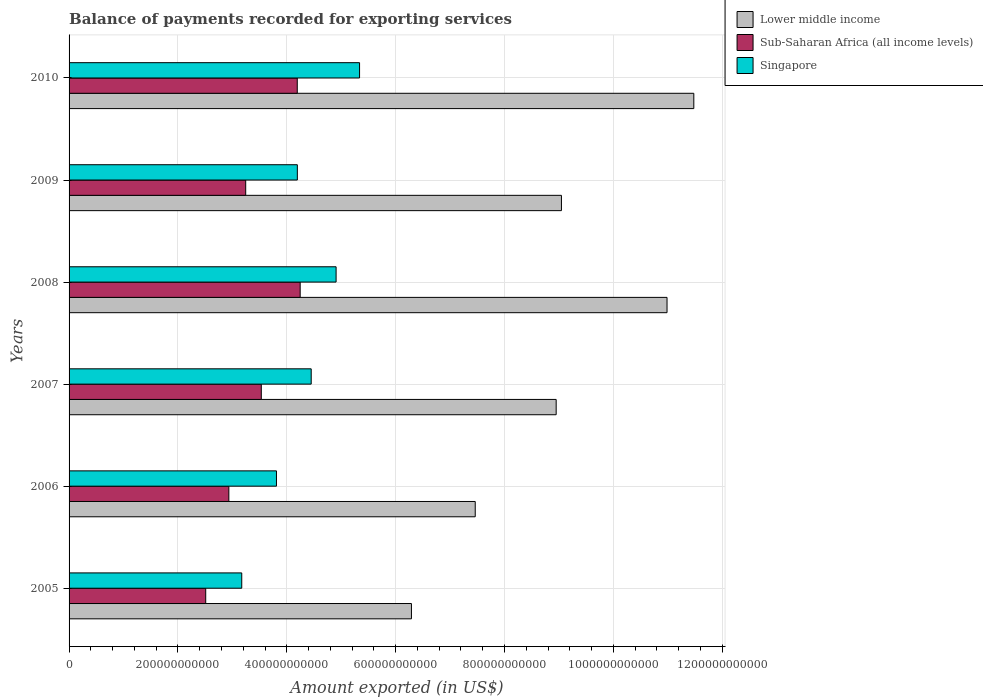Are the number of bars per tick equal to the number of legend labels?
Give a very brief answer. Yes. Are the number of bars on each tick of the Y-axis equal?
Offer a terse response. Yes. How many bars are there on the 5th tick from the bottom?
Your answer should be compact. 3. What is the label of the 2nd group of bars from the top?
Offer a terse response. 2009. In how many cases, is the number of bars for a given year not equal to the number of legend labels?
Provide a succinct answer. 0. What is the amount exported in Sub-Saharan Africa (all income levels) in 2009?
Your response must be concise. 3.25e+11. Across all years, what is the maximum amount exported in Lower middle income?
Your answer should be compact. 1.15e+12. Across all years, what is the minimum amount exported in Sub-Saharan Africa (all income levels)?
Make the answer very short. 2.51e+11. In which year was the amount exported in Lower middle income minimum?
Keep it short and to the point. 2005. What is the total amount exported in Lower middle income in the graph?
Provide a short and direct response. 5.42e+12. What is the difference between the amount exported in Lower middle income in 2007 and that in 2009?
Your answer should be compact. -9.69e+09. What is the difference between the amount exported in Sub-Saharan Africa (all income levels) in 2010 and the amount exported in Singapore in 2005?
Your answer should be very brief. 1.02e+11. What is the average amount exported in Sub-Saharan Africa (all income levels) per year?
Your answer should be very brief. 3.44e+11. In the year 2006, what is the difference between the amount exported in Sub-Saharan Africa (all income levels) and amount exported in Lower middle income?
Your answer should be compact. -4.53e+11. In how many years, is the amount exported in Lower middle income greater than 200000000000 US$?
Offer a very short reply. 6. What is the ratio of the amount exported in Lower middle income in 2005 to that in 2009?
Your answer should be compact. 0.7. Is the amount exported in Singapore in 2005 less than that in 2006?
Make the answer very short. Yes. What is the difference between the highest and the second highest amount exported in Lower middle income?
Ensure brevity in your answer.  4.92e+1. What is the difference between the highest and the lowest amount exported in Singapore?
Offer a very short reply. 2.16e+11. In how many years, is the amount exported in Singapore greater than the average amount exported in Singapore taken over all years?
Keep it short and to the point. 3. Is the sum of the amount exported in Sub-Saharan Africa (all income levels) in 2005 and 2007 greater than the maximum amount exported in Lower middle income across all years?
Make the answer very short. No. What does the 2nd bar from the top in 2007 represents?
Offer a very short reply. Sub-Saharan Africa (all income levels). What does the 3rd bar from the bottom in 2009 represents?
Keep it short and to the point. Singapore. Are all the bars in the graph horizontal?
Your response must be concise. Yes. What is the difference between two consecutive major ticks on the X-axis?
Your answer should be compact. 2.00e+11. Are the values on the major ticks of X-axis written in scientific E-notation?
Offer a very short reply. No. Where does the legend appear in the graph?
Your answer should be very brief. Top right. How many legend labels are there?
Make the answer very short. 3. What is the title of the graph?
Provide a short and direct response. Balance of payments recorded for exporting services. What is the label or title of the X-axis?
Offer a very short reply. Amount exported (in US$). What is the label or title of the Y-axis?
Offer a very short reply. Years. What is the Amount exported (in US$) in Lower middle income in 2005?
Provide a succinct answer. 6.29e+11. What is the Amount exported (in US$) in Sub-Saharan Africa (all income levels) in 2005?
Keep it short and to the point. 2.51e+11. What is the Amount exported (in US$) of Singapore in 2005?
Provide a succinct answer. 3.17e+11. What is the Amount exported (in US$) of Lower middle income in 2006?
Your answer should be very brief. 7.46e+11. What is the Amount exported (in US$) in Sub-Saharan Africa (all income levels) in 2006?
Your response must be concise. 2.94e+11. What is the Amount exported (in US$) in Singapore in 2006?
Provide a succinct answer. 3.81e+11. What is the Amount exported (in US$) of Lower middle income in 2007?
Ensure brevity in your answer.  8.95e+11. What is the Amount exported (in US$) in Sub-Saharan Africa (all income levels) in 2007?
Offer a terse response. 3.53e+11. What is the Amount exported (in US$) in Singapore in 2007?
Provide a short and direct response. 4.45e+11. What is the Amount exported (in US$) of Lower middle income in 2008?
Ensure brevity in your answer.  1.10e+12. What is the Amount exported (in US$) of Sub-Saharan Africa (all income levels) in 2008?
Your response must be concise. 4.25e+11. What is the Amount exported (in US$) in Singapore in 2008?
Offer a very short reply. 4.91e+11. What is the Amount exported (in US$) of Lower middle income in 2009?
Provide a short and direct response. 9.05e+11. What is the Amount exported (in US$) of Sub-Saharan Africa (all income levels) in 2009?
Make the answer very short. 3.25e+11. What is the Amount exported (in US$) in Singapore in 2009?
Offer a very short reply. 4.19e+11. What is the Amount exported (in US$) in Lower middle income in 2010?
Provide a short and direct response. 1.15e+12. What is the Amount exported (in US$) of Sub-Saharan Africa (all income levels) in 2010?
Provide a succinct answer. 4.19e+11. What is the Amount exported (in US$) in Singapore in 2010?
Offer a very short reply. 5.34e+11. Across all years, what is the maximum Amount exported (in US$) in Lower middle income?
Your response must be concise. 1.15e+12. Across all years, what is the maximum Amount exported (in US$) of Sub-Saharan Africa (all income levels)?
Your response must be concise. 4.25e+11. Across all years, what is the maximum Amount exported (in US$) of Singapore?
Offer a terse response. 5.34e+11. Across all years, what is the minimum Amount exported (in US$) of Lower middle income?
Provide a short and direct response. 6.29e+11. Across all years, what is the minimum Amount exported (in US$) in Sub-Saharan Africa (all income levels)?
Give a very brief answer. 2.51e+11. Across all years, what is the minimum Amount exported (in US$) in Singapore?
Keep it short and to the point. 3.17e+11. What is the total Amount exported (in US$) of Lower middle income in the graph?
Make the answer very short. 5.42e+12. What is the total Amount exported (in US$) in Sub-Saharan Africa (all income levels) in the graph?
Ensure brevity in your answer.  2.07e+12. What is the total Amount exported (in US$) in Singapore in the graph?
Provide a short and direct response. 2.59e+12. What is the difference between the Amount exported (in US$) of Lower middle income in 2005 and that in 2006?
Your response must be concise. -1.17e+11. What is the difference between the Amount exported (in US$) of Sub-Saharan Africa (all income levels) in 2005 and that in 2006?
Provide a short and direct response. -4.25e+1. What is the difference between the Amount exported (in US$) in Singapore in 2005 and that in 2006?
Offer a terse response. -6.38e+1. What is the difference between the Amount exported (in US$) of Lower middle income in 2005 and that in 2007?
Offer a very short reply. -2.66e+11. What is the difference between the Amount exported (in US$) of Sub-Saharan Africa (all income levels) in 2005 and that in 2007?
Offer a terse response. -1.02e+11. What is the difference between the Amount exported (in US$) in Singapore in 2005 and that in 2007?
Your answer should be compact. -1.28e+11. What is the difference between the Amount exported (in US$) of Lower middle income in 2005 and that in 2008?
Offer a very short reply. -4.70e+11. What is the difference between the Amount exported (in US$) in Sub-Saharan Africa (all income levels) in 2005 and that in 2008?
Offer a very short reply. -1.74e+11. What is the difference between the Amount exported (in US$) of Singapore in 2005 and that in 2008?
Your answer should be very brief. -1.73e+11. What is the difference between the Amount exported (in US$) in Lower middle income in 2005 and that in 2009?
Make the answer very short. -2.76e+11. What is the difference between the Amount exported (in US$) in Sub-Saharan Africa (all income levels) in 2005 and that in 2009?
Give a very brief answer. -7.35e+1. What is the difference between the Amount exported (in US$) in Singapore in 2005 and that in 2009?
Your response must be concise. -1.02e+11. What is the difference between the Amount exported (in US$) in Lower middle income in 2005 and that in 2010?
Your response must be concise. -5.19e+11. What is the difference between the Amount exported (in US$) in Sub-Saharan Africa (all income levels) in 2005 and that in 2010?
Provide a succinct answer. -1.68e+11. What is the difference between the Amount exported (in US$) in Singapore in 2005 and that in 2010?
Give a very brief answer. -2.16e+11. What is the difference between the Amount exported (in US$) of Lower middle income in 2006 and that in 2007?
Your answer should be compact. -1.49e+11. What is the difference between the Amount exported (in US$) of Sub-Saharan Africa (all income levels) in 2006 and that in 2007?
Make the answer very short. -5.96e+1. What is the difference between the Amount exported (in US$) in Singapore in 2006 and that in 2007?
Keep it short and to the point. -6.38e+1. What is the difference between the Amount exported (in US$) of Lower middle income in 2006 and that in 2008?
Ensure brevity in your answer.  -3.52e+11. What is the difference between the Amount exported (in US$) of Sub-Saharan Africa (all income levels) in 2006 and that in 2008?
Your answer should be very brief. -1.31e+11. What is the difference between the Amount exported (in US$) in Singapore in 2006 and that in 2008?
Your response must be concise. -1.10e+11. What is the difference between the Amount exported (in US$) of Lower middle income in 2006 and that in 2009?
Your answer should be compact. -1.58e+11. What is the difference between the Amount exported (in US$) in Sub-Saharan Africa (all income levels) in 2006 and that in 2009?
Provide a short and direct response. -3.10e+1. What is the difference between the Amount exported (in US$) of Singapore in 2006 and that in 2009?
Offer a terse response. -3.83e+1. What is the difference between the Amount exported (in US$) in Lower middle income in 2006 and that in 2010?
Provide a succinct answer. -4.02e+11. What is the difference between the Amount exported (in US$) of Sub-Saharan Africa (all income levels) in 2006 and that in 2010?
Your answer should be very brief. -1.26e+11. What is the difference between the Amount exported (in US$) in Singapore in 2006 and that in 2010?
Your answer should be very brief. -1.53e+11. What is the difference between the Amount exported (in US$) in Lower middle income in 2007 and that in 2008?
Offer a very short reply. -2.04e+11. What is the difference between the Amount exported (in US$) in Sub-Saharan Africa (all income levels) in 2007 and that in 2008?
Your response must be concise. -7.14e+1. What is the difference between the Amount exported (in US$) in Singapore in 2007 and that in 2008?
Provide a succinct answer. -4.57e+1. What is the difference between the Amount exported (in US$) in Lower middle income in 2007 and that in 2009?
Keep it short and to the point. -9.69e+09. What is the difference between the Amount exported (in US$) in Sub-Saharan Africa (all income levels) in 2007 and that in 2009?
Provide a succinct answer. 2.87e+1. What is the difference between the Amount exported (in US$) in Singapore in 2007 and that in 2009?
Provide a short and direct response. 2.55e+1. What is the difference between the Amount exported (in US$) of Lower middle income in 2007 and that in 2010?
Keep it short and to the point. -2.53e+11. What is the difference between the Amount exported (in US$) of Sub-Saharan Africa (all income levels) in 2007 and that in 2010?
Provide a short and direct response. -6.61e+1. What is the difference between the Amount exported (in US$) of Singapore in 2007 and that in 2010?
Offer a very short reply. -8.88e+1. What is the difference between the Amount exported (in US$) of Lower middle income in 2008 and that in 2009?
Ensure brevity in your answer.  1.94e+11. What is the difference between the Amount exported (in US$) of Sub-Saharan Africa (all income levels) in 2008 and that in 2009?
Give a very brief answer. 1.00e+11. What is the difference between the Amount exported (in US$) in Singapore in 2008 and that in 2009?
Offer a terse response. 7.12e+1. What is the difference between the Amount exported (in US$) in Lower middle income in 2008 and that in 2010?
Give a very brief answer. -4.92e+1. What is the difference between the Amount exported (in US$) in Sub-Saharan Africa (all income levels) in 2008 and that in 2010?
Keep it short and to the point. 5.35e+09. What is the difference between the Amount exported (in US$) in Singapore in 2008 and that in 2010?
Offer a terse response. -4.31e+1. What is the difference between the Amount exported (in US$) in Lower middle income in 2009 and that in 2010?
Your response must be concise. -2.43e+11. What is the difference between the Amount exported (in US$) of Sub-Saharan Africa (all income levels) in 2009 and that in 2010?
Offer a very short reply. -9.47e+1. What is the difference between the Amount exported (in US$) of Singapore in 2009 and that in 2010?
Ensure brevity in your answer.  -1.14e+11. What is the difference between the Amount exported (in US$) of Lower middle income in 2005 and the Amount exported (in US$) of Sub-Saharan Africa (all income levels) in 2006?
Your answer should be compact. 3.35e+11. What is the difference between the Amount exported (in US$) in Lower middle income in 2005 and the Amount exported (in US$) in Singapore in 2006?
Provide a short and direct response. 2.48e+11. What is the difference between the Amount exported (in US$) in Sub-Saharan Africa (all income levels) in 2005 and the Amount exported (in US$) in Singapore in 2006?
Keep it short and to the point. -1.30e+11. What is the difference between the Amount exported (in US$) in Lower middle income in 2005 and the Amount exported (in US$) in Sub-Saharan Africa (all income levels) in 2007?
Provide a short and direct response. 2.76e+11. What is the difference between the Amount exported (in US$) of Lower middle income in 2005 and the Amount exported (in US$) of Singapore in 2007?
Give a very brief answer. 1.84e+11. What is the difference between the Amount exported (in US$) in Sub-Saharan Africa (all income levels) in 2005 and the Amount exported (in US$) in Singapore in 2007?
Your answer should be compact. -1.94e+11. What is the difference between the Amount exported (in US$) of Lower middle income in 2005 and the Amount exported (in US$) of Sub-Saharan Africa (all income levels) in 2008?
Offer a very short reply. 2.04e+11. What is the difference between the Amount exported (in US$) in Lower middle income in 2005 and the Amount exported (in US$) in Singapore in 2008?
Your answer should be very brief. 1.38e+11. What is the difference between the Amount exported (in US$) in Sub-Saharan Africa (all income levels) in 2005 and the Amount exported (in US$) in Singapore in 2008?
Give a very brief answer. -2.40e+11. What is the difference between the Amount exported (in US$) in Lower middle income in 2005 and the Amount exported (in US$) in Sub-Saharan Africa (all income levels) in 2009?
Give a very brief answer. 3.05e+11. What is the difference between the Amount exported (in US$) in Lower middle income in 2005 and the Amount exported (in US$) in Singapore in 2009?
Your response must be concise. 2.10e+11. What is the difference between the Amount exported (in US$) in Sub-Saharan Africa (all income levels) in 2005 and the Amount exported (in US$) in Singapore in 2009?
Your answer should be compact. -1.68e+11. What is the difference between the Amount exported (in US$) in Lower middle income in 2005 and the Amount exported (in US$) in Sub-Saharan Africa (all income levels) in 2010?
Offer a terse response. 2.10e+11. What is the difference between the Amount exported (in US$) in Lower middle income in 2005 and the Amount exported (in US$) in Singapore in 2010?
Give a very brief answer. 9.53e+1. What is the difference between the Amount exported (in US$) of Sub-Saharan Africa (all income levels) in 2005 and the Amount exported (in US$) of Singapore in 2010?
Offer a very short reply. -2.83e+11. What is the difference between the Amount exported (in US$) of Lower middle income in 2006 and the Amount exported (in US$) of Sub-Saharan Africa (all income levels) in 2007?
Provide a short and direct response. 3.93e+11. What is the difference between the Amount exported (in US$) of Lower middle income in 2006 and the Amount exported (in US$) of Singapore in 2007?
Make the answer very short. 3.01e+11. What is the difference between the Amount exported (in US$) of Sub-Saharan Africa (all income levels) in 2006 and the Amount exported (in US$) of Singapore in 2007?
Offer a terse response. -1.51e+11. What is the difference between the Amount exported (in US$) of Lower middle income in 2006 and the Amount exported (in US$) of Sub-Saharan Africa (all income levels) in 2008?
Your answer should be very brief. 3.22e+11. What is the difference between the Amount exported (in US$) of Lower middle income in 2006 and the Amount exported (in US$) of Singapore in 2008?
Make the answer very short. 2.56e+11. What is the difference between the Amount exported (in US$) in Sub-Saharan Africa (all income levels) in 2006 and the Amount exported (in US$) in Singapore in 2008?
Your answer should be very brief. -1.97e+11. What is the difference between the Amount exported (in US$) in Lower middle income in 2006 and the Amount exported (in US$) in Sub-Saharan Africa (all income levels) in 2009?
Provide a short and direct response. 4.22e+11. What is the difference between the Amount exported (in US$) in Lower middle income in 2006 and the Amount exported (in US$) in Singapore in 2009?
Your answer should be compact. 3.27e+11. What is the difference between the Amount exported (in US$) of Sub-Saharan Africa (all income levels) in 2006 and the Amount exported (in US$) of Singapore in 2009?
Your answer should be very brief. -1.26e+11. What is the difference between the Amount exported (in US$) in Lower middle income in 2006 and the Amount exported (in US$) in Sub-Saharan Africa (all income levels) in 2010?
Make the answer very short. 3.27e+11. What is the difference between the Amount exported (in US$) in Lower middle income in 2006 and the Amount exported (in US$) in Singapore in 2010?
Provide a succinct answer. 2.13e+11. What is the difference between the Amount exported (in US$) in Sub-Saharan Africa (all income levels) in 2006 and the Amount exported (in US$) in Singapore in 2010?
Ensure brevity in your answer.  -2.40e+11. What is the difference between the Amount exported (in US$) in Lower middle income in 2007 and the Amount exported (in US$) in Sub-Saharan Africa (all income levels) in 2008?
Provide a succinct answer. 4.70e+11. What is the difference between the Amount exported (in US$) in Lower middle income in 2007 and the Amount exported (in US$) in Singapore in 2008?
Your answer should be compact. 4.04e+11. What is the difference between the Amount exported (in US$) of Sub-Saharan Africa (all income levels) in 2007 and the Amount exported (in US$) of Singapore in 2008?
Offer a very short reply. -1.37e+11. What is the difference between the Amount exported (in US$) in Lower middle income in 2007 and the Amount exported (in US$) in Sub-Saharan Africa (all income levels) in 2009?
Provide a short and direct response. 5.70e+11. What is the difference between the Amount exported (in US$) of Lower middle income in 2007 and the Amount exported (in US$) of Singapore in 2009?
Your answer should be compact. 4.76e+11. What is the difference between the Amount exported (in US$) of Sub-Saharan Africa (all income levels) in 2007 and the Amount exported (in US$) of Singapore in 2009?
Your response must be concise. -6.62e+1. What is the difference between the Amount exported (in US$) in Lower middle income in 2007 and the Amount exported (in US$) in Sub-Saharan Africa (all income levels) in 2010?
Your answer should be very brief. 4.76e+11. What is the difference between the Amount exported (in US$) of Lower middle income in 2007 and the Amount exported (in US$) of Singapore in 2010?
Your response must be concise. 3.61e+11. What is the difference between the Amount exported (in US$) in Sub-Saharan Africa (all income levels) in 2007 and the Amount exported (in US$) in Singapore in 2010?
Provide a short and direct response. -1.81e+11. What is the difference between the Amount exported (in US$) of Lower middle income in 2008 and the Amount exported (in US$) of Sub-Saharan Africa (all income levels) in 2009?
Your response must be concise. 7.74e+11. What is the difference between the Amount exported (in US$) in Lower middle income in 2008 and the Amount exported (in US$) in Singapore in 2009?
Your response must be concise. 6.79e+11. What is the difference between the Amount exported (in US$) of Sub-Saharan Africa (all income levels) in 2008 and the Amount exported (in US$) of Singapore in 2009?
Keep it short and to the point. 5.20e+09. What is the difference between the Amount exported (in US$) of Lower middle income in 2008 and the Amount exported (in US$) of Sub-Saharan Africa (all income levels) in 2010?
Offer a terse response. 6.79e+11. What is the difference between the Amount exported (in US$) in Lower middle income in 2008 and the Amount exported (in US$) in Singapore in 2010?
Keep it short and to the point. 5.65e+11. What is the difference between the Amount exported (in US$) in Sub-Saharan Africa (all income levels) in 2008 and the Amount exported (in US$) in Singapore in 2010?
Ensure brevity in your answer.  -1.09e+11. What is the difference between the Amount exported (in US$) in Lower middle income in 2009 and the Amount exported (in US$) in Sub-Saharan Africa (all income levels) in 2010?
Your answer should be compact. 4.85e+11. What is the difference between the Amount exported (in US$) of Lower middle income in 2009 and the Amount exported (in US$) of Singapore in 2010?
Your response must be concise. 3.71e+11. What is the difference between the Amount exported (in US$) in Sub-Saharan Africa (all income levels) in 2009 and the Amount exported (in US$) in Singapore in 2010?
Provide a succinct answer. -2.09e+11. What is the average Amount exported (in US$) of Lower middle income per year?
Your response must be concise. 9.04e+11. What is the average Amount exported (in US$) of Sub-Saharan Africa (all income levels) per year?
Your response must be concise. 3.44e+11. What is the average Amount exported (in US$) of Singapore per year?
Make the answer very short. 4.31e+11. In the year 2005, what is the difference between the Amount exported (in US$) of Lower middle income and Amount exported (in US$) of Sub-Saharan Africa (all income levels)?
Make the answer very short. 3.78e+11. In the year 2005, what is the difference between the Amount exported (in US$) of Lower middle income and Amount exported (in US$) of Singapore?
Offer a terse response. 3.12e+11. In the year 2005, what is the difference between the Amount exported (in US$) of Sub-Saharan Africa (all income levels) and Amount exported (in US$) of Singapore?
Your answer should be compact. -6.62e+1. In the year 2006, what is the difference between the Amount exported (in US$) of Lower middle income and Amount exported (in US$) of Sub-Saharan Africa (all income levels)?
Your answer should be very brief. 4.53e+11. In the year 2006, what is the difference between the Amount exported (in US$) of Lower middle income and Amount exported (in US$) of Singapore?
Your answer should be very brief. 3.65e+11. In the year 2006, what is the difference between the Amount exported (in US$) of Sub-Saharan Africa (all income levels) and Amount exported (in US$) of Singapore?
Your response must be concise. -8.75e+1. In the year 2007, what is the difference between the Amount exported (in US$) of Lower middle income and Amount exported (in US$) of Sub-Saharan Africa (all income levels)?
Give a very brief answer. 5.42e+11. In the year 2007, what is the difference between the Amount exported (in US$) of Lower middle income and Amount exported (in US$) of Singapore?
Your answer should be compact. 4.50e+11. In the year 2007, what is the difference between the Amount exported (in US$) of Sub-Saharan Africa (all income levels) and Amount exported (in US$) of Singapore?
Your answer should be very brief. -9.17e+1. In the year 2008, what is the difference between the Amount exported (in US$) of Lower middle income and Amount exported (in US$) of Sub-Saharan Africa (all income levels)?
Make the answer very short. 6.74e+11. In the year 2008, what is the difference between the Amount exported (in US$) of Lower middle income and Amount exported (in US$) of Singapore?
Make the answer very short. 6.08e+11. In the year 2008, what is the difference between the Amount exported (in US$) of Sub-Saharan Africa (all income levels) and Amount exported (in US$) of Singapore?
Give a very brief answer. -6.60e+1. In the year 2009, what is the difference between the Amount exported (in US$) in Lower middle income and Amount exported (in US$) in Sub-Saharan Africa (all income levels)?
Ensure brevity in your answer.  5.80e+11. In the year 2009, what is the difference between the Amount exported (in US$) in Lower middle income and Amount exported (in US$) in Singapore?
Keep it short and to the point. 4.85e+11. In the year 2009, what is the difference between the Amount exported (in US$) in Sub-Saharan Africa (all income levels) and Amount exported (in US$) in Singapore?
Give a very brief answer. -9.49e+1. In the year 2010, what is the difference between the Amount exported (in US$) of Lower middle income and Amount exported (in US$) of Sub-Saharan Africa (all income levels)?
Offer a very short reply. 7.29e+11. In the year 2010, what is the difference between the Amount exported (in US$) in Lower middle income and Amount exported (in US$) in Singapore?
Keep it short and to the point. 6.14e+11. In the year 2010, what is the difference between the Amount exported (in US$) of Sub-Saharan Africa (all income levels) and Amount exported (in US$) of Singapore?
Offer a very short reply. -1.14e+11. What is the ratio of the Amount exported (in US$) of Lower middle income in 2005 to that in 2006?
Your answer should be very brief. 0.84. What is the ratio of the Amount exported (in US$) of Sub-Saharan Africa (all income levels) in 2005 to that in 2006?
Offer a terse response. 0.86. What is the ratio of the Amount exported (in US$) of Singapore in 2005 to that in 2006?
Keep it short and to the point. 0.83. What is the ratio of the Amount exported (in US$) in Lower middle income in 2005 to that in 2007?
Offer a very short reply. 0.7. What is the ratio of the Amount exported (in US$) in Sub-Saharan Africa (all income levels) in 2005 to that in 2007?
Provide a succinct answer. 0.71. What is the ratio of the Amount exported (in US$) in Singapore in 2005 to that in 2007?
Offer a terse response. 0.71. What is the ratio of the Amount exported (in US$) in Lower middle income in 2005 to that in 2008?
Your response must be concise. 0.57. What is the ratio of the Amount exported (in US$) of Sub-Saharan Africa (all income levels) in 2005 to that in 2008?
Keep it short and to the point. 0.59. What is the ratio of the Amount exported (in US$) of Singapore in 2005 to that in 2008?
Make the answer very short. 0.65. What is the ratio of the Amount exported (in US$) in Lower middle income in 2005 to that in 2009?
Provide a succinct answer. 0.7. What is the ratio of the Amount exported (in US$) in Sub-Saharan Africa (all income levels) in 2005 to that in 2009?
Offer a very short reply. 0.77. What is the ratio of the Amount exported (in US$) of Singapore in 2005 to that in 2009?
Offer a very short reply. 0.76. What is the ratio of the Amount exported (in US$) in Lower middle income in 2005 to that in 2010?
Provide a succinct answer. 0.55. What is the ratio of the Amount exported (in US$) in Sub-Saharan Africa (all income levels) in 2005 to that in 2010?
Your answer should be compact. 0.6. What is the ratio of the Amount exported (in US$) of Singapore in 2005 to that in 2010?
Offer a very short reply. 0.59. What is the ratio of the Amount exported (in US$) in Lower middle income in 2006 to that in 2007?
Offer a terse response. 0.83. What is the ratio of the Amount exported (in US$) of Sub-Saharan Africa (all income levels) in 2006 to that in 2007?
Provide a short and direct response. 0.83. What is the ratio of the Amount exported (in US$) in Singapore in 2006 to that in 2007?
Make the answer very short. 0.86. What is the ratio of the Amount exported (in US$) in Lower middle income in 2006 to that in 2008?
Ensure brevity in your answer.  0.68. What is the ratio of the Amount exported (in US$) of Sub-Saharan Africa (all income levels) in 2006 to that in 2008?
Make the answer very short. 0.69. What is the ratio of the Amount exported (in US$) in Singapore in 2006 to that in 2008?
Offer a very short reply. 0.78. What is the ratio of the Amount exported (in US$) in Lower middle income in 2006 to that in 2009?
Ensure brevity in your answer.  0.82. What is the ratio of the Amount exported (in US$) of Sub-Saharan Africa (all income levels) in 2006 to that in 2009?
Offer a very short reply. 0.9. What is the ratio of the Amount exported (in US$) of Singapore in 2006 to that in 2009?
Ensure brevity in your answer.  0.91. What is the ratio of the Amount exported (in US$) in Lower middle income in 2006 to that in 2010?
Provide a succinct answer. 0.65. What is the ratio of the Amount exported (in US$) in Sub-Saharan Africa (all income levels) in 2006 to that in 2010?
Your response must be concise. 0.7. What is the ratio of the Amount exported (in US$) in Singapore in 2006 to that in 2010?
Provide a short and direct response. 0.71. What is the ratio of the Amount exported (in US$) in Lower middle income in 2007 to that in 2008?
Provide a succinct answer. 0.81. What is the ratio of the Amount exported (in US$) of Sub-Saharan Africa (all income levels) in 2007 to that in 2008?
Provide a short and direct response. 0.83. What is the ratio of the Amount exported (in US$) in Singapore in 2007 to that in 2008?
Offer a very short reply. 0.91. What is the ratio of the Amount exported (in US$) of Lower middle income in 2007 to that in 2009?
Your response must be concise. 0.99. What is the ratio of the Amount exported (in US$) of Sub-Saharan Africa (all income levels) in 2007 to that in 2009?
Make the answer very short. 1.09. What is the ratio of the Amount exported (in US$) in Singapore in 2007 to that in 2009?
Your answer should be very brief. 1.06. What is the ratio of the Amount exported (in US$) of Lower middle income in 2007 to that in 2010?
Provide a short and direct response. 0.78. What is the ratio of the Amount exported (in US$) of Sub-Saharan Africa (all income levels) in 2007 to that in 2010?
Keep it short and to the point. 0.84. What is the ratio of the Amount exported (in US$) in Singapore in 2007 to that in 2010?
Make the answer very short. 0.83. What is the ratio of the Amount exported (in US$) of Lower middle income in 2008 to that in 2009?
Your answer should be compact. 1.21. What is the ratio of the Amount exported (in US$) of Sub-Saharan Africa (all income levels) in 2008 to that in 2009?
Your answer should be very brief. 1.31. What is the ratio of the Amount exported (in US$) of Singapore in 2008 to that in 2009?
Provide a short and direct response. 1.17. What is the ratio of the Amount exported (in US$) of Lower middle income in 2008 to that in 2010?
Make the answer very short. 0.96. What is the ratio of the Amount exported (in US$) in Sub-Saharan Africa (all income levels) in 2008 to that in 2010?
Provide a succinct answer. 1.01. What is the ratio of the Amount exported (in US$) of Singapore in 2008 to that in 2010?
Make the answer very short. 0.92. What is the ratio of the Amount exported (in US$) in Lower middle income in 2009 to that in 2010?
Offer a very short reply. 0.79. What is the ratio of the Amount exported (in US$) of Sub-Saharan Africa (all income levels) in 2009 to that in 2010?
Ensure brevity in your answer.  0.77. What is the ratio of the Amount exported (in US$) of Singapore in 2009 to that in 2010?
Provide a short and direct response. 0.79. What is the difference between the highest and the second highest Amount exported (in US$) of Lower middle income?
Ensure brevity in your answer.  4.92e+1. What is the difference between the highest and the second highest Amount exported (in US$) of Sub-Saharan Africa (all income levels)?
Your answer should be compact. 5.35e+09. What is the difference between the highest and the second highest Amount exported (in US$) of Singapore?
Offer a very short reply. 4.31e+1. What is the difference between the highest and the lowest Amount exported (in US$) in Lower middle income?
Your answer should be compact. 5.19e+11. What is the difference between the highest and the lowest Amount exported (in US$) of Sub-Saharan Africa (all income levels)?
Offer a very short reply. 1.74e+11. What is the difference between the highest and the lowest Amount exported (in US$) of Singapore?
Offer a terse response. 2.16e+11. 